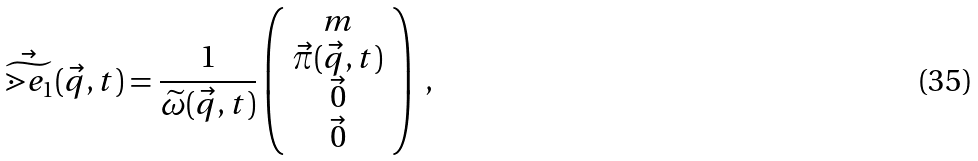Convert formula to latex. <formula><loc_0><loc_0><loc_500><loc_500>\vec { \widetilde { \mathbb { m } { e } } } _ { 1 } ( \vec { q } , t ) = \frac { 1 } { \widetilde { \omega } ( \vec { q } , t ) } \left ( \begin{array} { c } m \\ \vec { \pi } ( \vec { q } , t ) \\ \vec { 0 } \\ \vec { 0 } \end{array} \right ) \ ,</formula> 